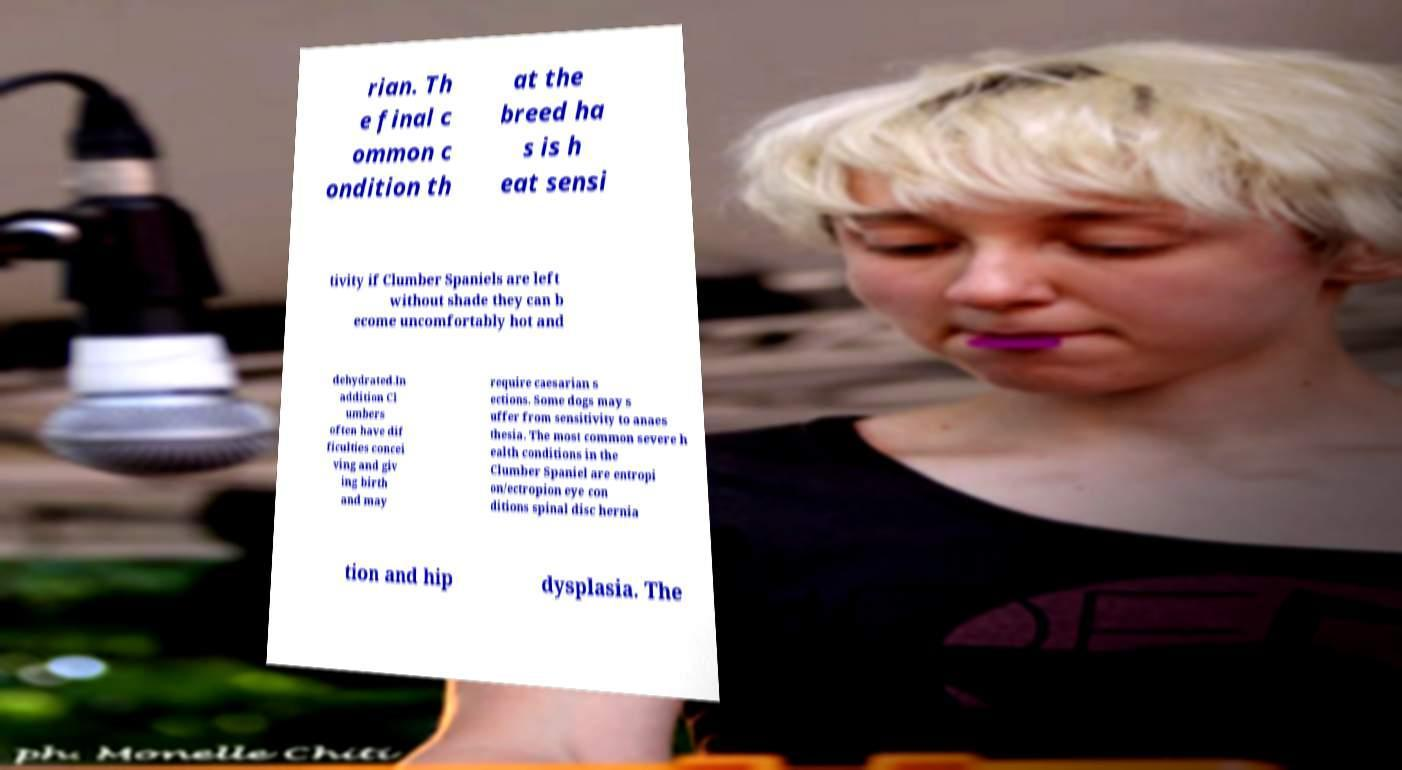Can you read and provide the text displayed in the image?This photo seems to have some interesting text. Can you extract and type it out for me? rian. Th e final c ommon c ondition th at the breed ha s is h eat sensi tivity if Clumber Spaniels are left without shade they can b ecome uncomfortably hot and dehydrated.In addition Cl umbers often have dif ficulties concei ving and giv ing birth and may require caesarian s ections. Some dogs may s uffer from sensitivity to anaes thesia. The most common severe h ealth conditions in the Clumber Spaniel are entropi on/ectropion eye con ditions spinal disc hernia tion and hip dysplasia. The 